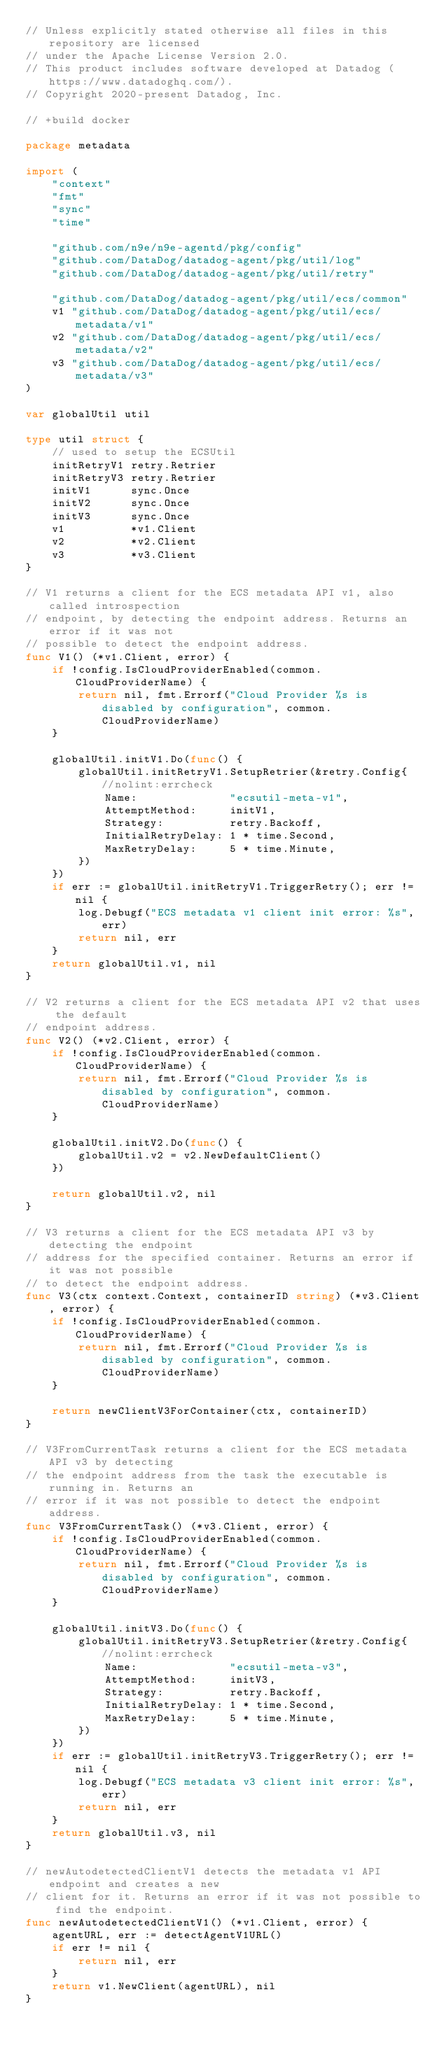Convert code to text. <code><loc_0><loc_0><loc_500><loc_500><_Go_>// Unless explicitly stated otherwise all files in this repository are licensed
// under the Apache License Version 2.0.
// This product includes software developed at Datadog (https://www.datadoghq.com/).
// Copyright 2020-present Datadog, Inc.

// +build docker

package metadata

import (
	"context"
	"fmt"
	"sync"
	"time"

	"github.com/n9e/n9e-agentd/pkg/config"
	"github.com/DataDog/datadog-agent/pkg/util/log"
	"github.com/DataDog/datadog-agent/pkg/util/retry"

	"github.com/DataDog/datadog-agent/pkg/util/ecs/common"
	v1 "github.com/DataDog/datadog-agent/pkg/util/ecs/metadata/v1"
	v2 "github.com/DataDog/datadog-agent/pkg/util/ecs/metadata/v2"
	v3 "github.com/DataDog/datadog-agent/pkg/util/ecs/metadata/v3"
)

var globalUtil util

type util struct {
	// used to setup the ECSUtil
	initRetryV1 retry.Retrier
	initRetryV3 retry.Retrier
	initV1      sync.Once
	initV2      sync.Once
	initV3      sync.Once
	v1          *v1.Client
	v2          *v2.Client
	v3          *v3.Client
}

// V1 returns a client for the ECS metadata API v1, also called introspection
// endpoint, by detecting the endpoint address. Returns an error if it was not
// possible to detect the endpoint address.
func V1() (*v1.Client, error) {
	if !config.IsCloudProviderEnabled(common.CloudProviderName) {
		return nil, fmt.Errorf("Cloud Provider %s is disabled by configuration", common.CloudProviderName)
	}

	globalUtil.initV1.Do(func() {
		globalUtil.initRetryV1.SetupRetrier(&retry.Config{ //nolint:errcheck
			Name:              "ecsutil-meta-v1",
			AttemptMethod:     initV1,
			Strategy:          retry.Backoff,
			InitialRetryDelay: 1 * time.Second,
			MaxRetryDelay:     5 * time.Minute,
		})
	})
	if err := globalUtil.initRetryV1.TriggerRetry(); err != nil {
		log.Debugf("ECS metadata v1 client init error: %s", err)
		return nil, err
	}
	return globalUtil.v1, nil
}

// V2 returns a client for the ECS metadata API v2 that uses the default
// endpoint address.
func V2() (*v2.Client, error) {
	if !config.IsCloudProviderEnabled(common.CloudProviderName) {
		return nil, fmt.Errorf("Cloud Provider %s is disabled by configuration", common.CloudProviderName)
	}

	globalUtil.initV2.Do(func() {
		globalUtil.v2 = v2.NewDefaultClient()
	})

	return globalUtil.v2, nil
}

// V3 returns a client for the ECS metadata API v3 by detecting the endpoint
// address for the specified container. Returns an error if it was not possible
// to detect the endpoint address.
func V3(ctx context.Context, containerID string) (*v3.Client, error) {
	if !config.IsCloudProviderEnabled(common.CloudProviderName) {
		return nil, fmt.Errorf("Cloud Provider %s is disabled by configuration", common.CloudProviderName)
	}

	return newClientV3ForContainer(ctx, containerID)
}

// V3FromCurrentTask returns a client for the ECS metadata API v3 by detecting
// the endpoint address from the task the executable is running in. Returns an
// error if it was not possible to detect the endpoint address.
func V3FromCurrentTask() (*v3.Client, error) {
	if !config.IsCloudProviderEnabled(common.CloudProviderName) {
		return nil, fmt.Errorf("Cloud Provider %s is disabled by configuration", common.CloudProviderName)
	}

	globalUtil.initV3.Do(func() {
		globalUtil.initRetryV3.SetupRetrier(&retry.Config{ //nolint:errcheck
			Name:              "ecsutil-meta-v3",
			AttemptMethod:     initV3,
			Strategy:          retry.Backoff,
			InitialRetryDelay: 1 * time.Second,
			MaxRetryDelay:     5 * time.Minute,
		})
	})
	if err := globalUtil.initRetryV3.TriggerRetry(); err != nil {
		log.Debugf("ECS metadata v3 client init error: %s", err)
		return nil, err
	}
	return globalUtil.v3, nil
}

// newAutodetectedClientV1 detects the metadata v1 API endpoint and creates a new
// client for it. Returns an error if it was not possible to find the endpoint.
func newAutodetectedClientV1() (*v1.Client, error) {
	agentURL, err := detectAgentV1URL()
	if err != nil {
		return nil, err
	}
	return v1.NewClient(agentURL), nil
}
</code> 